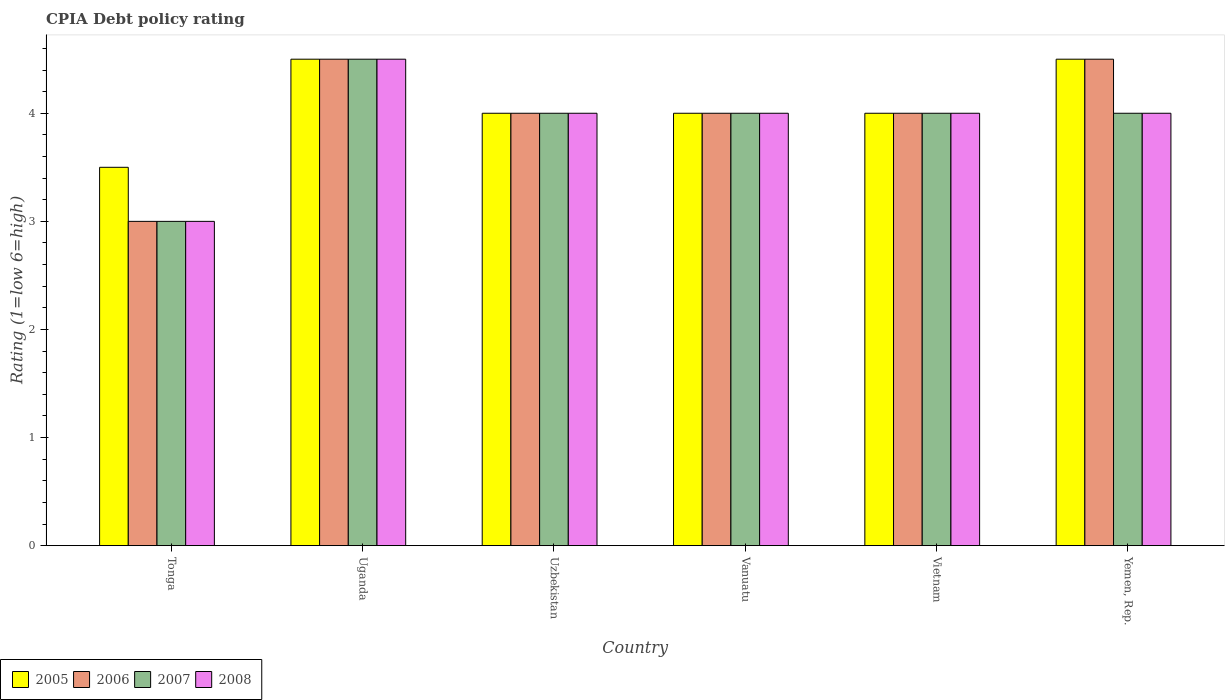Are the number of bars per tick equal to the number of legend labels?
Give a very brief answer. Yes. Are the number of bars on each tick of the X-axis equal?
Ensure brevity in your answer.  Yes. What is the label of the 3rd group of bars from the left?
Your answer should be very brief. Uzbekistan. In which country was the CPIA rating in 2005 maximum?
Provide a succinct answer. Uganda. In which country was the CPIA rating in 2008 minimum?
Provide a succinct answer. Tonga. What is the total CPIA rating in 2007 in the graph?
Your answer should be compact. 23.5. What is the difference between the CPIA rating in 2008 in Uzbekistan and the CPIA rating in 2005 in Vietnam?
Keep it short and to the point. 0. What is the average CPIA rating in 2007 per country?
Offer a very short reply. 3.92. What is the ratio of the CPIA rating in 2008 in Tonga to that in Uganda?
Offer a terse response. 0.67. Is the CPIA rating in 2005 in Tonga less than that in Yemen, Rep.?
Keep it short and to the point. Yes. Is the difference between the CPIA rating in 2007 in Uganda and Uzbekistan greater than the difference between the CPIA rating in 2005 in Uganda and Uzbekistan?
Your response must be concise. No. What is the difference between the highest and the second highest CPIA rating in 2005?
Offer a terse response. 0.5. What is the difference between the highest and the lowest CPIA rating in 2005?
Make the answer very short. 1. In how many countries, is the CPIA rating in 2007 greater than the average CPIA rating in 2007 taken over all countries?
Keep it short and to the point. 5. Is the sum of the CPIA rating in 2005 in Uzbekistan and Vietnam greater than the maximum CPIA rating in 2008 across all countries?
Provide a short and direct response. Yes. Is it the case that in every country, the sum of the CPIA rating in 2005 and CPIA rating in 2008 is greater than the sum of CPIA rating in 2007 and CPIA rating in 2006?
Your response must be concise. No. Are all the bars in the graph horizontal?
Your answer should be very brief. No. Does the graph contain any zero values?
Keep it short and to the point. No. How many legend labels are there?
Keep it short and to the point. 4. How are the legend labels stacked?
Keep it short and to the point. Horizontal. What is the title of the graph?
Offer a very short reply. CPIA Debt policy rating. Does "1993" appear as one of the legend labels in the graph?
Your response must be concise. No. What is the label or title of the Y-axis?
Ensure brevity in your answer.  Rating (1=low 6=high). What is the Rating (1=low 6=high) in 2006 in Tonga?
Your answer should be compact. 3. What is the Rating (1=low 6=high) in 2008 in Tonga?
Ensure brevity in your answer.  3. What is the Rating (1=low 6=high) of 2005 in Uganda?
Your response must be concise. 4.5. What is the Rating (1=low 6=high) of 2006 in Uganda?
Your answer should be compact. 4.5. What is the Rating (1=low 6=high) in 2007 in Uganda?
Your answer should be compact. 4.5. What is the Rating (1=low 6=high) in 2008 in Uganda?
Give a very brief answer. 4.5. What is the Rating (1=low 6=high) in 2006 in Vanuatu?
Your response must be concise. 4. What is the Rating (1=low 6=high) in 2005 in Vietnam?
Give a very brief answer. 4. What is the Rating (1=low 6=high) in 2006 in Vietnam?
Your answer should be compact. 4. What is the Rating (1=low 6=high) in 2008 in Vietnam?
Your answer should be compact. 4. What is the Rating (1=low 6=high) in 2005 in Yemen, Rep.?
Give a very brief answer. 4.5. What is the Rating (1=low 6=high) in 2007 in Yemen, Rep.?
Your answer should be compact. 4. Across all countries, what is the maximum Rating (1=low 6=high) of 2005?
Provide a short and direct response. 4.5. Across all countries, what is the minimum Rating (1=low 6=high) of 2008?
Ensure brevity in your answer.  3. What is the total Rating (1=low 6=high) of 2007 in the graph?
Your answer should be very brief. 23.5. What is the total Rating (1=low 6=high) of 2008 in the graph?
Your answer should be very brief. 23.5. What is the difference between the Rating (1=low 6=high) of 2006 in Tonga and that in Uganda?
Your response must be concise. -1.5. What is the difference between the Rating (1=low 6=high) of 2007 in Tonga and that in Uganda?
Your response must be concise. -1.5. What is the difference between the Rating (1=low 6=high) in 2005 in Tonga and that in Uzbekistan?
Your response must be concise. -0.5. What is the difference between the Rating (1=low 6=high) in 2007 in Tonga and that in Uzbekistan?
Keep it short and to the point. -1. What is the difference between the Rating (1=low 6=high) in 2007 in Tonga and that in Vanuatu?
Give a very brief answer. -1. What is the difference between the Rating (1=low 6=high) of 2005 in Tonga and that in Yemen, Rep.?
Your answer should be compact. -1. What is the difference between the Rating (1=low 6=high) in 2006 in Tonga and that in Yemen, Rep.?
Provide a short and direct response. -1.5. What is the difference between the Rating (1=low 6=high) of 2007 in Tonga and that in Yemen, Rep.?
Give a very brief answer. -1. What is the difference between the Rating (1=low 6=high) in 2008 in Tonga and that in Yemen, Rep.?
Keep it short and to the point. -1. What is the difference between the Rating (1=low 6=high) in 2007 in Uganda and that in Uzbekistan?
Provide a succinct answer. 0.5. What is the difference between the Rating (1=low 6=high) in 2005 in Uganda and that in Vanuatu?
Provide a succinct answer. 0.5. What is the difference between the Rating (1=low 6=high) in 2006 in Uganda and that in Vanuatu?
Keep it short and to the point. 0.5. What is the difference between the Rating (1=low 6=high) in 2007 in Uganda and that in Vanuatu?
Ensure brevity in your answer.  0.5. What is the difference between the Rating (1=low 6=high) in 2005 in Uganda and that in Vietnam?
Your answer should be compact. 0.5. What is the difference between the Rating (1=low 6=high) of 2006 in Uganda and that in Vietnam?
Give a very brief answer. 0.5. What is the difference between the Rating (1=low 6=high) of 2006 in Uganda and that in Yemen, Rep.?
Make the answer very short. 0. What is the difference between the Rating (1=low 6=high) of 2007 in Uganda and that in Yemen, Rep.?
Make the answer very short. 0.5. What is the difference between the Rating (1=low 6=high) in 2008 in Uganda and that in Yemen, Rep.?
Ensure brevity in your answer.  0.5. What is the difference between the Rating (1=low 6=high) in 2007 in Uzbekistan and that in Vanuatu?
Provide a short and direct response. 0. What is the difference between the Rating (1=low 6=high) in 2005 in Uzbekistan and that in Yemen, Rep.?
Provide a short and direct response. -0.5. What is the difference between the Rating (1=low 6=high) of 2008 in Uzbekistan and that in Yemen, Rep.?
Your answer should be compact. 0. What is the difference between the Rating (1=low 6=high) of 2006 in Vanuatu and that in Vietnam?
Ensure brevity in your answer.  0. What is the difference between the Rating (1=low 6=high) of 2008 in Vanuatu and that in Vietnam?
Your answer should be very brief. 0. What is the difference between the Rating (1=low 6=high) in 2005 in Vanuatu and that in Yemen, Rep.?
Provide a short and direct response. -0.5. What is the difference between the Rating (1=low 6=high) in 2005 in Vietnam and that in Yemen, Rep.?
Your response must be concise. -0.5. What is the difference between the Rating (1=low 6=high) in 2007 in Vietnam and that in Yemen, Rep.?
Ensure brevity in your answer.  0. What is the difference between the Rating (1=low 6=high) in 2008 in Vietnam and that in Yemen, Rep.?
Provide a succinct answer. 0. What is the difference between the Rating (1=low 6=high) in 2005 in Tonga and the Rating (1=low 6=high) in 2006 in Uganda?
Offer a very short reply. -1. What is the difference between the Rating (1=low 6=high) in 2006 in Tonga and the Rating (1=low 6=high) in 2007 in Uganda?
Provide a short and direct response. -1.5. What is the difference between the Rating (1=low 6=high) of 2006 in Tonga and the Rating (1=low 6=high) of 2008 in Uganda?
Your answer should be compact. -1.5. What is the difference between the Rating (1=low 6=high) of 2005 in Tonga and the Rating (1=low 6=high) of 2008 in Uzbekistan?
Give a very brief answer. -0.5. What is the difference between the Rating (1=low 6=high) in 2006 in Tonga and the Rating (1=low 6=high) in 2008 in Uzbekistan?
Provide a succinct answer. -1. What is the difference between the Rating (1=low 6=high) of 2005 in Tonga and the Rating (1=low 6=high) of 2006 in Vanuatu?
Make the answer very short. -0.5. What is the difference between the Rating (1=low 6=high) of 2005 in Tonga and the Rating (1=low 6=high) of 2007 in Vanuatu?
Ensure brevity in your answer.  -0.5. What is the difference between the Rating (1=low 6=high) of 2005 in Tonga and the Rating (1=low 6=high) of 2008 in Vanuatu?
Provide a succinct answer. -0.5. What is the difference between the Rating (1=low 6=high) in 2007 in Tonga and the Rating (1=low 6=high) in 2008 in Vanuatu?
Make the answer very short. -1. What is the difference between the Rating (1=low 6=high) in 2005 in Tonga and the Rating (1=low 6=high) in 2006 in Vietnam?
Offer a terse response. -0.5. What is the difference between the Rating (1=low 6=high) of 2005 in Tonga and the Rating (1=low 6=high) of 2007 in Vietnam?
Keep it short and to the point. -0.5. What is the difference between the Rating (1=low 6=high) in 2005 in Tonga and the Rating (1=low 6=high) in 2008 in Vietnam?
Provide a short and direct response. -0.5. What is the difference between the Rating (1=low 6=high) of 2005 in Tonga and the Rating (1=low 6=high) of 2008 in Yemen, Rep.?
Offer a terse response. -0.5. What is the difference between the Rating (1=low 6=high) of 2006 in Tonga and the Rating (1=low 6=high) of 2007 in Yemen, Rep.?
Provide a succinct answer. -1. What is the difference between the Rating (1=low 6=high) of 2005 in Uganda and the Rating (1=low 6=high) of 2007 in Uzbekistan?
Give a very brief answer. 0.5. What is the difference between the Rating (1=low 6=high) of 2005 in Uganda and the Rating (1=low 6=high) of 2008 in Uzbekistan?
Provide a succinct answer. 0.5. What is the difference between the Rating (1=low 6=high) of 2006 in Uganda and the Rating (1=low 6=high) of 2007 in Uzbekistan?
Give a very brief answer. 0.5. What is the difference between the Rating (1=low 6=high) in 2005 in Uganda and the Rating (1=low 6=high) in 2007 in Vanuatu?
Ensure brevity in your answer.  0.5. What is the difference between the Rating (1=low 6=high) of 2006 in Uganda and the Rating (1=low 6=high) of 2007 in Vanuatu?
Ensure brevity in your answer.  0.5. What is the difference between the Rating (1=low 6=high) in 2006 in Uganda and the Rating (1=low 6=high) in 2008 in Vanuatu?
Keep it short and to the point. 0.5. What is the difference between the Rating (1=low 6=high) of 2007 in Uganda and the Rating (1=low 6=high) of 2008 in Vanuatu?
Keep it short and to the point. 0.5. What is the difference between the Rating (1=low 6=high) of 2005 in Uganda and the Rating (1=low 6=high) of 2006 in Vietnam?
Provide a succinct answer. 0.5. What is the difference between the Rating (1=low 6=high) of 2005 in Uganda and the Rating (1=low 6=high) of 2007 in Vietnam?
Your answer should be compact. 0.5. What is the difference between the Rating (1=low 6=high) in 2005 in Uganda and the Rating (1=low 6=high) in 2008 in Vietnam?
Keep it short and to the point. 0.5. What is the difference between the Rating (1=low 6=high) of 2006 in Uganda and the Rating (1=low 6=high) of 2007 in Vietnam?
Your answer should be very brief. 0.5. What is the difference between the Rating (1=low 6=high) of 2006 in Uganda and the Rating (1=low 6=high) of 2008 in Vietnam?
Offer a very short reply. 0.5. What is the difference between the Rating (1=low 6=high) of 2007 in Uganda and the Rating (1=low 6=high) of 2008 in Vietnam?
Keep it short and to the point. 0.5. What is the difference between the Rating (1=low 6=high) in 2005 in Uganda and the Rating (1=low 6=high) in 2007 in Yemen, Rep.?
Offer a very short reply. 0.5. What is the difference between the Rating (1=low 6=high) in 2005 in Uganda and the Rating (1=low 6=high) in 2008 in Yemen, Rep.?
Give a very brief answer. 0.5. What is the difference between the Rating (1=low 6=high) in 2005 in Uzbekistan and the Rating (1=low 6=high) in 2008 in Vanuatu?
Offer a very short reply. 0. What is the difference between the Rating (1=low 6=high) of 2006 in Uzbekistan and the Rating (1=low 6=high) of 2007 in Vanuatu?
Give a very brief answer. 0. What is the difference between the Rating (1=low 6=high) in 2006 in Uzbekistan and the Rating (1=low 6=high) in 2008 in Vanuatu?
Your answer should be very brief. 0. What is the difference between the Rating (1=low 6=high) of 2005 in Uzbekistan and the Rating (1=low 6=high) of 2007 in Vietnam?
Make the answer very short. 0. What is the difference between the Rating (1=low 6=high) in 2007 in Uzbekistan and the Rating (1=low 6=high) in 2008 in Vietnam?
Ensure brevity in your answer.  0. What is the difference between the Rating (1=low 6=high) in 2005 in Uzbekistan and the Rating (1=low 6=high) in 2007 in Yemen, Rep.?
Keep it short and to the point. 0. What is the difference between the Rating (1=low 6=high) in 2006 in Uzbekistan and the Rating (1=low 6=high) in 2007 in Yemen, Rep.?
Offer a very short reply. 0. What is the difference between the Rating (1=low 6=high) of 2006 in Uzbekistan and the Rating (1=low 6=high) of 2008 in Yemen, Rep.?
Make the answer very short. 0. What is the difference between the Rating (1=low 6=high) in 2007 in Uzbekistan and the Rating (1=low 6=high) in 2008 in Yemen, Rep.?
Your answer should be very brief. 0. What is the difference between the Rating (1=low 6=high) in 2005 in Vanuatu and the Rating (1=low 6=high) in 2006 in Vietnam?
Offer a terse response. 0. What is the difference between the Rating (1=low 6=high) of 2005 in Vanuatu and the Rating (1=low 6=high) of 2007 in Vietnam?
Make the answer very short. 0. What is the difference between the Rating (1=low 6=high) of 2005 in Vanuatu and the Rating (1=low 6=high) of 2008 in Vietnam?
Make the answer very short. 0. What is the difference between the Rating (1=low 6=high) in 2006 in Vanuatu and the Rating (1=low 6=high) in 2008 in Vietnam?
Your response must be concise. 0. What is the difference between the Rating (1=low 6=high) of 2005 in Vanuatu and the Rating (1=low 6=high) of 2006 in Yemen, Rep.?
Provide a short and direct response. -0.5. What is the difference between the Rating (1=low 6=high) in 2005 in Vanuatu and the Rating (1=low 6=high) in 2008 in Yemen, Rep.?
Your answer should be compact. 0. What is the difference between the Rating (1=low 6=high) of 2006 in Vanuatu and the Rating (1=low 6=high) of 2008 in Yemen, Rep.?
Keep it short and to the point. 0. What is the difference between the Rating (1=low 6=high) of 2007 in Vanuatu and the Rating (1=low 6=high) of 2008 in Yemen, Rep.?
Make the answer very short. 0. What is the difference between the Rating (1=low 6=high) of 2005 in Vietnam and the Rating (1=low 6=high) of 2008 in Yemen, Rep.?
Provide a succinct answer. 0. What is the difference between the Rating (1=low 6=high) in 2007 in Vietnam and the Rating (1=low 6=high) in 2008 in Yemen, Rep.?
Your response must be concise. 0. What is the average Rating (1=low 6=high) of 2005 per country?
Your response must be concise. 4.08. What is the average Rating (1=low 6=high) of 2006 per country?
Your answer should be compact. 4. What is the average Rating (1=low 6=high) of 2007 per country?
Keep it short and to the point. 3.92. What is the average Rating (1=low 6=high) in 2008 per country?
Your answer should be very brief. 3.92. What is the difference between the Rating (1=low 6=high) in 2005 and Rating (1=low 6=high) in 2006 in Tonga?
Offer a very short reply. 0.5. What is the difference between the Rating (1=low 6=high) of 2005 and Rating (1=low 6=high) of 2007 in Tonga?
Ensure brevity in your answer.  0.5. What is the difference between the Rating (1=low 6=high) in 2006 and Rating (1=low 6=high) in 2008 in Tonga?
Your response must be concise. 0. What is the difference between the Rating (1=low 6=high) in 2007 and Rating (1=low 6=high) in 2008 in Tonga?
Your answer should be very brief. 0. What is the difference between the Rating (1=low 6=high) in 2005 and Rating (1=low 6=high) in 2006 in Uganda?
Your answer should be compact. 0. What is the difference between the Rating (1=low 6=high) of 2006 and Rating (1=low 6=high) of 2007 in Uganda?
Provide a succinct answer. 0. What is the difference between the Rating (1=low 6=high) of 2007 and Rating (1=low 6=high) of 2008 in Uganda?
Your answer should be very brief. 0. What is the difference between the Rating (1=low 6=high) of 2005 and Rating (1=low 6=high) of 2006 in Uzbekistan?
Ensure brevity in your answer.  0. What is the difference between the Rating (1=low 6=high) in 2005 and Rating (1=low 6=high) in 2007 in Uzbekistan?
Give a very brief answer. 0. What is the difference between the Rating (1=low 6=high) of 2006 and Rating (1=low 6=high) of 2007 in Uzbekistan?
Provide a short and direct response. 0. What is the difference between the Rating (1=low 6=high) of 2007 and Rating (1=low 6=high) of 2008 in Uzbekistan?
Offer a terse response. 0. What is the difference between the Rating (1=low 6=high) in 2006 and Rating (1=low 6=high) in 2008 in Vanuatu?
Provide a succinct answer. 0. What is the difference between the Rating (1=low 6=high) of 2005 and Rating (1=low 6=high) of 2006 in Vietnam?
Offer a very short reply. 0. What is the difference between the Rating (1=low 6=high) in 2005 and Rating (1=low 6=high) in 2008 in Vietnam?
Your answer should be very brief. 0. What is the difference between the Rating (1=low 6=high) in 2007 and Rating (1=low 6=high) in 2008 in Vietnam?
Provide a succinct answer. 0. What is the difference between the Rating (1=low 6=high) of 2005 and Rating (1=low 6=high) of 2006 in Yemen, Rep.?
Offer a very short reply. 0. What is the difference between the Rating (1=low 6=high) of 2005 and Rating (1=low 6=high) of 2007 in Yemen, Rep.?
Make the answer very short. 0.5. What is the difference between the Rating (1=low 6=high) of 2005 and Rating (1=low 6=high) of 2008 in Yemen, Rep.?
Provide a short and direct response. 0.5. What is the difference between the Rating (1=low 6=high) in 2006 and Rating (1=low 6=high) in 2008 in Yemen, Rep.?
Your answer should be compact. 0.5. What is the ratio of the Rating (1=low 6=high) in 2008 in Tonga to that in Uganda?
Offer a very short reply. 0.67. What is the ratio of the Rating (1=low 6=high) of 2007 in Tonga to that in Uzbekistan?
Provide a short and direct response. 0.75. What is the ratio of the Rating (1=low 6=high) of 2008 in Tonga to that in Uzbekistan?
Give a very brief answer. 0.75. What is the ratio of the Rating (1=low 6=high) of 2005 in Tonga to that in Vanuatu?
Make the answer very short. 0.88. What is the ratio of the Rating (1=low 6=high) in 2006 in Tonga to that in Vanuatu?
Offer a very short reply. 0.75. What is the ratio of the Rating (1=low 6=high) of 2008 in Tonga to that in Vanuatu?
Ensure brevity in your answer.  0.75. What is the ratio of the Rating (1=low 6=high) of 2005 in Tonga to that in Vietnam?
Make the answer very short. 0.88. What is the ratio of the Rating (1=low 6=high) in 2006 in Tonga to that in Vietnam?
Provide a succinct answer. 0.75. What is the ratio of the Rating (1=low 6=high) of 2008 in Tonga to that in Vietnam?
Keep it short and to the point. 0.75. What is the ratio of the Rating (1=low 6=high) of 2006 in Tonga to that in Yemen, Rep.?
Offer a very short reply. 0.67. What is the ratio of the Rating (1=low 6=high) of 2008 in Tonga to that in Yemen, Rep.?
Offer a very short reply. 0.75. What is the ratio of the Rating (1=low 6=high) in 2007 in Uganda to that in Uzbekistan?
Keep it short and to the point. 1.12. What is the ratio of the Rating (1=low 6=high) of 2008 in Uganda to that in Uzbekistan?
Your response must be concise. 1.12. What is the ratio of the Rating (1=low 6=high) in 2005 in Uganda to that in Vanuatu?
Provide a short and direct response. 1.12. What is the ratio of the Rating (1=low 6=high) of 2008 in Uganda to that in Vanuatu?
Ensure brevity in your answer.  1.12. What is the ratio of the Rating (1=low 6=high) in 2008 in Uganda to that in Vietnam?
Your response must be concise. 1.12. What is the ratio of the Rating (1=low 6=high) in 2006 in Uganda to that in Yemen, Rep.?
Your answer should be compact. 1. What is the ratio of the Rating (1=low 6=high) of 2005 in Uzbekistan to that in Vanuatu?
Give a very brief answer. 1. What is the ratio of the Rating (1=low 6=high) of 2007 in Uzbekistan to that in Vanuatu?
Your answer should be very brief. 1. What is the ratio of the Rating (1=low 6=high) of 2008 in Uzbekistan to that in Vietnam?
Keep it short and to the point. 1. What is the ratio of the Rating (1=low 6=high) of 2008 in Uzbekistan to that in Yemen, Rep.?
Provide a succinct answer. 1. What is the ratio of the Rating (1=low 6=high) of 2005 in Vanuatu to that in Vietnam?
Your response must be concise. 1. What is the ratio of the Rating (1=low 6=high) in 2005 in Vanuatu to that in Yemen, Rep.?
Your answer should be compact. 0.89. What is the ratio of the Rating (1=low 6=high) in 2006 in Vanuatu to that in Yemen, Rep.?
Offer a very short reply. 0.89. What is the ratio of the Rating (1=low 6=high) of 2005 in Vietnam to that in Yemen, Rep.?
Your answer should be compact. 0.89. What is the ratio of the Rating (1=low 6=high) in 2006 in Vietnam to that in Yemen, Rep.?
Make the answer very short. 0.89. What is the ratio of the Rating (1=low 6=high) of 2007 in Vietnam to that in Yemen, Rep.?
Your answer should be very brief. 1. What is the ratio of the Rating (1=low 6=high) in 2008 in Vietnam to that in Yemen, Rep.?
Provide a succinct answer. 1. What is the difference between the highest and the second highest Rating (1=low 6=high) of 2005?
Provide a short and direct response. 0. What is the difference between the highest and the second highest Rating (1=low 6=high) in 2006?
Make the answer very short. 0. What is the difference between the highest and the lowest Rating (1=low 6=high) in 2008?
Provide a succinct answer. 1.5. 